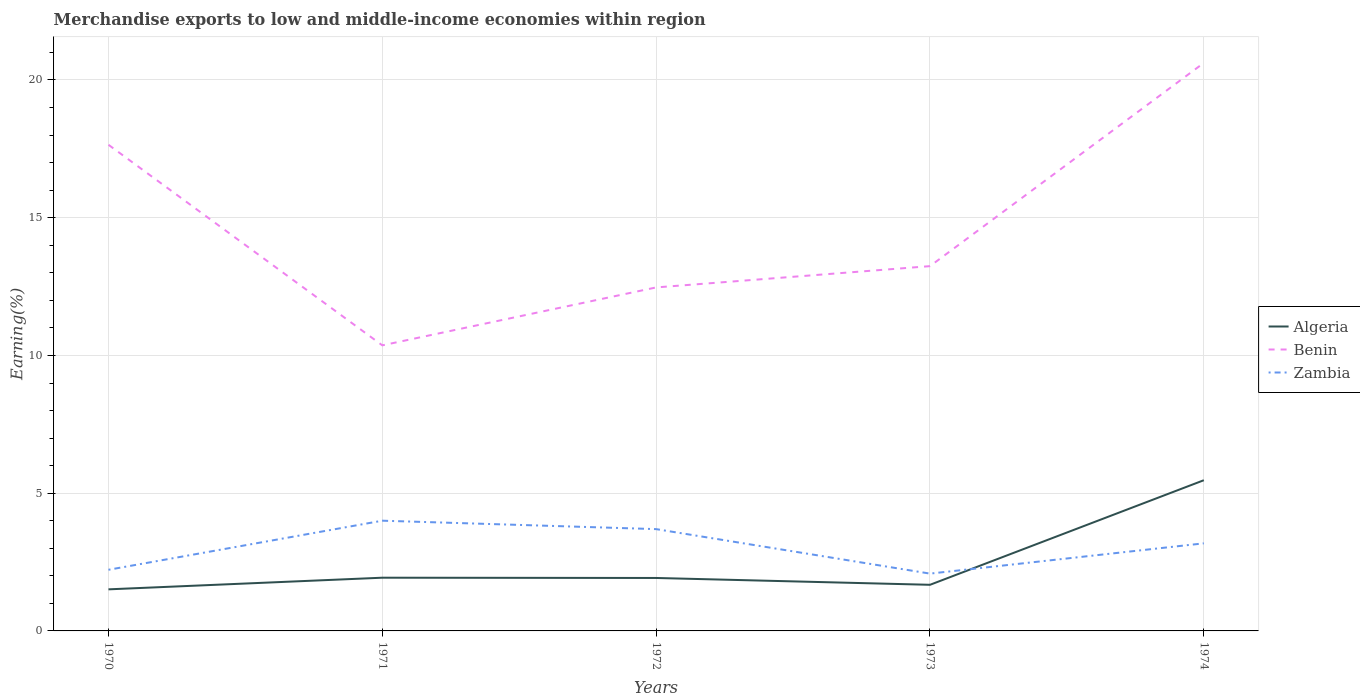How many different coloured lines are there?
Keep it short and to the point. 3. Across all years, what is the maximum percentage of amount earned from merchandise exports in Algeria?
Offer a very short reply. 1.51. In which year was the percentage of amount earned from merchandise exports in Zambia maximum?
Your response must be concise. 1973. What is the total percentage of amount earned from merchandise exports in Algeria in the graph?
Your answer should be compact. 0.01. What is the difference between the highest and the second highest percentage of amount earned from merchandise exports in Algeria?
Provide a succinct answer. 3.96. What is the difference between the highest and the lowest percentage of amount earned from merchandise exports in Algeria?
Your answer should be compact. 1. Is the percentage of amount earned from merchandise exports in Benin strictly greater than the percentage of amount earned from merchandise exports in Algeria over the years?
Keep it short and to the point. No. How many lines are there?
Give a very brief answer. 3. How many years are there in the graph?
Your answer should be compact. 5. Does the graph contain grids?
Give a very brief answer. Yes. Where does the legend appear in the graph?
Offer a very short reply. Center right. How many legend labels are there?
Keep it short and to the point. 3. What is the title of the graph?
Offer a very short reply. Merchandise exports to low and middle-income economies within region. What is the label or title of the Y-axis?
Provide a short and direct response. Earning(%). What is the Earning(%) of Algeria in 1970?
Offer a terse response. 1.51. What is the Earning(%) in Benin in 1970?
Ensure brevity in your answer.  17.65. What is the Earning(%) in Zambia in 1970?
Keep it short and to the point. 2.22. What is the Earning(%) of Algeria in 1971?
Your response must be concise. 1.93. What is the Earning(%) in Benin in 1971?
Your response must be concise. 10.37. What is the Earning(%) of Zambia in 1971?
Your response must be concise. 4. What is the Earning(%) in Algeria in 1972?
Offer a terse response. 1.92. What is the Earning(%) in Benin in 1972?
Keep it short and to the point. 12.47. What is the Earning(%) in Zambia in 1972?
Provide a succinct answer. 3.7. What is the Earning(%) of Algeria in 1973?
Offer a very short reply. 1.67. What is the Earning(%) in Benin in 1973?
Provide a short and direct response. 13.24. What is the Earning(%) of Zambia in 1973?
Provide a short and direct response. 2.08. What is the Earning(%) in Algeria in 1974?
Keep it short and to the point. 5.47. What is the Earning(%) of Benin in 1974?
Your response must be concise. 20.62. What is the Earning(%) of Zambia in 1974?
Your answer should be very brief. 3.18. Across all years, what is the maximum Earning(%) in Algeria?
Provide a succinct answer. 5.47. Across all years, what is the maximum Earning(%) of Benin?
Ensure brevity in your answer.  20.62. Across all years, what is the maximum Earning(%) in Zambia?
Offer a very short reply. 4. Across all years, what is the minimum Earning(%) of Algeria?
Provide a succinct answer. 1.51. Across all years, what is the minimum Earning(%) in Benin?
Offer a terse response. 10.37. Across all years, what is the minimum Earning(%) in Zambia?
Make the answer very short. 2.08. What is the total Earning(%) of Algeria in the graph?
Ensure brevity in your answer.  12.51. What is the total Earning(%) of Benin in the graph?
Give a very brief answer. 74.35. What is the total Earning(%) in Zambia in the graph?
Ensure brevity in your answer.  15.18. What is the difference between the Earning(%) in Algeria in 1970 and that in 1971?
Your response must be concise. -0.42. What is the difference between the Earning(%) in Benin in 1970 and that in 1971?
Give a very brief answer. 7.28. What is the difference between the Earning(%) of Zambia in 1970 and that in 1971?
Your answer should be compact. -1.78. What is the difference between the Earning(%) of Algeria in 1970 and that in 1972?
Give a very brief answer. -0.41. What is the difference between the Earning(%) in Benin in 1970 and that in 1972?
Offer a terse response. 5.18. What is the difference between the Earning(%) in Zambia in 1970 and that in 1972?
Provide a short and direct response. -1.48. What is the difference between the Earning(%) of Algeria in 1970 and that in 1973?
Provide a short and direct response. -0.17. What is the difference between the Earning(%) of Benin in 1970 and that in 1973?
Give a very brief answer. 4.41. What is the difference between the Earning(%) of Zambia in 1970 and that in 1973?
Make the answer very short. 0.14. What is the difference between the Earning(%) of Algeria in 1970 and that in 1974?
Your answer should be compact. -3.96. What is the difference between the Earning(%) of Benin in 1970 and that in 1974?
Your answer should be very brief. -2.97. What is the difference between the Earning(%) in Zambia in 1970 and that in 1974?
Provide a short and direct response. -0.96. What is the difference between the Earning(%) of Benin in 1971 and that in 1972?
Provide a short and direct response. -2.1. What is the difference between the Earning(%) of Zambia in 1971 and that in 1972?
Your response must be concise. 0.31. What is the difference between the Earning(%) of Algeria in 1971 and that in 1973?
Provide a short and direct response. 0.26. What is the difference between the Earning(%) in Benin in 1971 and that in 1973?
Keep it short and to the point. -2.88. What is the difference between the Earning(%) of Zambia in 1971 and that in 1973?
Your answer should be very brief. 1.92. What is the difference between the Earning(%) in Algeria in 1971 and that in 1974?
Ensure brevity in your answer.  -3.54. What is the difference between the Earning(%) of Benin in 1971 and that in 1974?
Your answer should be compact. -10.25. What is the difference between the Earning(%) in Zambia in 1971 and that in 1974?
Give a very brief answer. 0.82. What is the difference between the Earning(%) of Algeria in 1972 and that in 1973?
Give a very brief answer. 0.25. What is the difference between the Earning(%) of Benin in 1972 and that in 1973?
Offer a terse response. -0.77. What is the difference between the Earning(%) in Zambia in 1972 and that in 1973?
Your answer should be very brief. 1.61. What is the difference between the Earning(%) in Algeria in 1972 and that in 1974?
Give a very brief answer. -3.55. What is the difference between the Earning(%) in Benin in 1972 and that in 1974?
Your response must be concise. -8.15. What is the difference between the Earning(%) of Zambia in 1972 and that in 1974?
Ensure brevity in your answer.  0.52. What is the difference between the Earning(%) in Algeria in 1973 and that in 1974?
Your answer should be compact. -3.8. What is the difference between the Earning(%) of Benin in 1973 and that in 1974?
Ensure brevity in your answer.  -7.38. What is the difference between the Earning(%) in Zambia in 1973 and that in 1974?
Provide a short and direct response. -1.1. What is the difference between the Earning(%) in Algeria in 1970 and the Earning(%) in Benin in 1971?
Provide a short and direct response. -8.86. What is the difference between the Earning(%) in Algeria in 1970 and the Earning(%) in Zambia in 1971?
Provide a succinct answer. -2.49. What is the difference between the Earning(%) in Benin in 1970 and the Earning(%) in Zambia in 1971?
Your answer should be very brief. 13.65. What is the difference between the Earning(%) in Algeria in 1970 and the Earning(%) in Benin in 1972?
Provide a short and direct response. -10.96. What is the difference between the Earning(%) of Algeria in 1970 and the Earning(%) of Zambia in 1972?
Give a very brief answer. -2.19. What is the difference between the Earning(%) of Benin in 1970 and the Earning(%) of Zambia in 1972?
Offer a very short reply. 13.95. What is the difference between the Earning(%) in Algeria in 1970 and the Earning(%) in Benin in 1973?
Keep it short and to the point. -11.73. What is the difference between the Earning(%) of Algeria in 1970 and the Earning(%) of Zambia in 1973?
Your answer should be compact. -0.57. What is the difference between the Earning(%) in Benin in 1970 and the Earning(%) in Zambia in 1973?
Your answer should be compact. 15.57. What is the difference between the Earning(%) of Algeria in 1970 and the Earning(%) of Benin in 1974?
Keep it short and to the point. -19.11. What is the difference between the Earning(%) of Algeria in 1970 and the Earning(%) of Zambia in 1974?
Give a very brief answer. -1.67. What is the difference between the Earning(%) in Benin in 1970 and the Earning(%) in Zambia in 1974?
Provide a short and direct response. 14.47. What is the difference between the Earning(%) in Algeria in 1971 and the Earning(%) in Benin in 1972?
Offer a terse response. -10.54. What is the difference between the Earning(%) of Algeria in 1971 and the Earning(%) of Zambia in 1972?
Keep it short and to the point. -1.76. What is the difference between the Earning(%) in Benin in 1971 and the Earning(%) in Zambia in 1972?
Your answer should be very brief. 6.67. What is the difference between the Earning(%) in Algeria in 1971 and the Earning(%) in Benin in 1973?
Offer a terse response. -11.31. What is the difference between the Earning(%) of Algeria in 1971 and the Earning(%) of Zambia in 1973?
Your answer should be compact. -0.15. What is the difference between the Earning(%) in Benin in 1971 and the Earning(%) in Zambia in 1973?
Offer a very short reply. 8.29. What is the difference between the Earning(%) in Algeria in 1971 and the Earning(%) in Benin in 1974?
Make the answer very short. -18.69. What is the difference between the Earning(%) in Algeria in 1971 and the Earning(%) in Zambia in 1974?
Offer a very short reply. -1.25. What is the difference between the Earning(%) of Benin in 1971 and the Earning(%) of Zambia in 1974?
Your answer should be compact. 7.19. What is the difference between the Earning(%) in Algeria in 1972 and the Earning(%) in Benin in 1973?
Your response must be concise. -11.32. What is the difference between the Earning(%) of Algeria in 1972 and the Earning(%) of Zambia in 1973?
Make the answer very short. -0.16. What is the difference between the Earning(%) of Benin in 1972 and the Earning(%) of Zambia in 1973?
Offer a very short reply. 10.39. What is the difference between the Earning(%) of Algeria in 1972 and the Earning(%) of Benin in 1974?
Your answer should be very brief. -18.7. What is the difference between the Earning(%) in Algeria in 1972 and the Earning(%) in Zambia in 1974?
Your response must be concise. -1.26. What is the difference between the Earning(%) of Benin in 1972 and the Earning(%) of Zambia in 1974?
Provide a short and direct response. 9.29. What is the difference between the Earning(%) of Algeria in 1973 and the Earning(%) of Benin in 1974?
Ensure brevity in your answer.  -18.95. What is the difference between the Earning(%) of Algeria in 1973 and the Earning(%) of Zambia in 1974?
Your response must be concise. -1.51. What is the difference between the Earning(%) of Benin in 1973 and the Earning(%) of Zambia in 1974?
Provide a short and direct response. 10.06. What is the average Earning(%) in Algeria per year?
Keep it short and to the point. 2.5. What is the average Earning(%) in Benin per year?
Your answer should be compact. 14.87. What is the average Earning(%) in Zambia per year?
Make the answer very short. 3.04. In the year 1970, what is the difference between the Earning(%) of Algeria and Earning(%) of Benin?
Ensure brevity in your answer.  -16.14. In the year 1970, what is the difference between the Earning(%) of Algeria and Earning(%) of Zambia?
Your response must be concise. -0.71. In the year 1970, what is the difference between the Earning(%) in Benin and Earning(%) in Zambia?
Your response must be concise. 15.43. In the year 1971, what is the difference between the Earning(%) in Algeria and Earning(%) in Benin?
Your answer should be compact. -8.44. In the year 1971, what is the difference between the Earning(%) of Algeria and Earning(%) of Zambia?
Ensure brevity in your answer.  -2.07. In the year 1971, what is the difference between the Earning(%) in Benin and Earning(%) in Zambia?
Your answer should be compact. 6.37. In the year 1972, what is the difference between the Earning(%) in Algeria and Earning(%) in Benin?
Your answer should be compact. -10.55. In the year 1972, what is the difference between the Earning(%) of Algeria and Earning(%) of Zambia?
Keep it short and to the point. -1.77. In the year 1972, what is the difference between the Earning(%) of Benin and Earning(%) of Zambia?
Offer a very short reply. 8.77. In the year 1973, what is the difference between the Earning(%) of Algeria and Earning(%) of Benin?
Your response must be concise. -11.57. In the year 1973, what is the difference between the Earning(%) of Algeria and Earning(%) of Zambia?
Your response must be concise. -0.41. In the year 1973, what is the difference between the Earning(%) of Benin and Earning(%) of Zambia?
Ensure brevity in your answer.  11.16. In the year 1974, what is the difference between the Earning(%) of Algeria and Earning(%) of Benin?
Your response must be concise. -15.15. In the year 1974, what is the difference between the Earning(%) of Algeria and Earning(%) of Zambia?
Provide a succinct answer. 2.29. In the year 1974, what is the difference between the Earning(%) of Benin and Earning(%) of Zambia?
Offer a very short reply. 17.44. What is the ratio of the Earning(%) of Algeria in 1970 to that in 1971?
Make the answer very short. 0.78. What is the ratio of the Earning(%) in Benin in 1970 to that in 1971?
Keep it short and to the point. 1.7. What is the ratio of the Earning(%) of Zambia in 1970 to that in 1971?
Provide a succinct answer. 0.55. What is the ratio of the Earning(%) of Algeria in 1970 to that in 1972?
Ensure brevity in your answer.  0.79. What is the ratio of the Earning(%) in Benin in 1970 to that in 1972?
Offer a terse response. 1.42. What is the ratio of the Earning(%) in Zambia in 1970 to that in 1972?
Offer a very short reply. 0.6. What is the ratio of the Earning(%) of Algeria in 1970 to that in 1973?
Your answer should be very brief. 0.9. What is the ratio of the Earning(%) of Benin in 1970 to that in 1973?
Ensure brevity in your answer.  1.33. What is the ratio of the Earning(%) in Zambia in 1970 to that in 1973?
Give a very brief answer. 1.07. What is the ratio of the Earning(%) of Algeria in 1970 to that in 1974?
Offer a terse response. 0.28. What is the ratio of the Earning(%) of Benin in 1970 to that in 1974?
Your answer should be very brief. 0.86. What is the ratio of the Earning(%) of Zambia in 1970 to that in 1974?
Ensure brevity in your answer.  0.7. What is the ratio of the Earning(%) in Algeria in 1971 to that in 1972?
Give a very brief answer. 1.01. What is the ratio of the Earning(%) in Benin in 1971 to that in 1972?
Your response must be concise. 0.83. What is the ratio of the Earning(%) in Zambia in 1971 to that in 1972?
Your answer should be compact. 1.08. What is the ratio of the Earning(%) of Algeria in 1971 to that in 1973?
Provide a short and direct response. 1.15. What is the ratio of the Earning(%) of Benin in 1971 to that in 1973?
Make the answer very short. 0.78. What is the ratio of the Earning(%) of Zambia in 1971 to that in 1973?
Keep it short and to the point. 1.92. What is the ratio of the Earning(%) in Algeria in 1971 to that in 1974?
Offer a terse response. 0.35. What is the ratio of the Earning(%) in Benin in 1971 to that in 1974?
Offer a terse response. 0.5. What is the ratio of the Earning(%) of Zambia in 1971 to that in 1974?
Offer a terse response. 1.26. What is the ratio of the Earning(%) in Algeria in 1972 to that in 1973?
Your response must be concise. 1.15. What is the ratio of the Earning(%) of Benin in 1972 to that in 1973?
Offer a terse response. 0.94. What is the ratio of the Earning(%) of Zambia in 1972 to that in 1973?
Provide a short and direct response. 1.78. What is the ratio of the Earning(%) in Algeria in 1972 to that in 1974?
Offer a very short reply. 0.35. What is the ratio of the Earning(%) in Benin in 1972 to that in 1974?
Offer a terse response. 0.6. What is the ratio of the Earning(%) of Zambia in 1972 to that in 1974?
Your answer should be compact. 1.16. What is the ratio of the Earning(%) in Algeria in 1973 to that in 1974?
Your response must be concise. 0.31. What is the ratio of the Earning(%) of Benin in 1973 to that in 1974?
Provide a succinct answer. 0.64. What is the ratio of the Earning(%) of Zambia in 1973 to that in 1974?
Offer a terse response. 0.65. What is the difference between the highest and the second highest Earning(%) of Algeria?
Provide a succinct answer. 3.54. What is the difference between the highest and the second highest Earning(%) in Benin?
Offer a terse response. 2.97. What is the difference between the highest and the second highest Earning(%) of Zambia?
Your response must be concise. 0.31. What is the difference between the highest and the lowest Earning(%) of Algeria?
Make the answer very short. 3.96. What is the difference between the highest and the lowest Earning(%) of Benin?
Provide a succinct answer. 10.25. What is the difference between the highest and the lowest Earning(%) in Zambia?
Your answer should be compact. 1.92. 